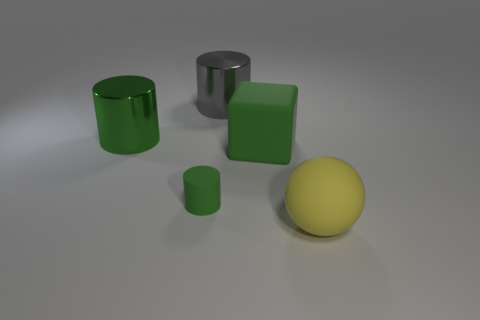Subtract all green cylinders. How many cylinders are left? 1 Add 2 green blocks. How many objects exist? 7 Subtract 1 blocks. How many blocks are left? 0 Subtract all green cylinders. How many cylinders are left? 1 Subtract all cylinders. How many objects are left? 2 Subtract all tiny yellow balls. Subtract all large green rubber objects. How many objects are left? 4 Add 5 matte spheres. How many matte spheres are left? 6 Add 1 gray cylinders. How many gray cylinders exist? 2 Subtract 0 gray balls. How many objects are left? 5 Subtract all gray blocks. Subtract all gray spheres. How many blocks are left? 1 